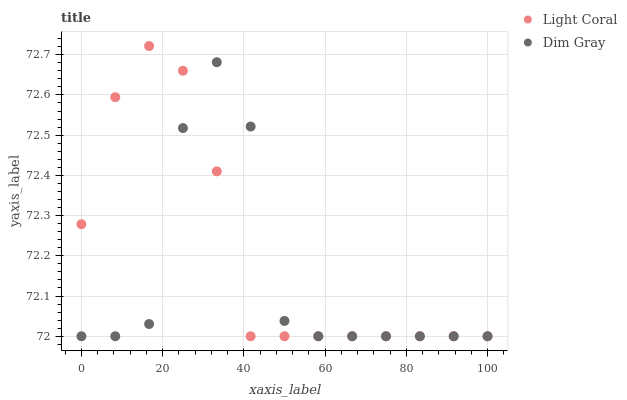Does Dim Gray have the minimum area under the curve?
Answer yes or no. Yes. Does Light Coral have the maximum area under the curve?
Answer yes or no. Yes. Does Dim Gray have the maximum area under the curve?
Answer yes or no. No. Is Light Coral the smoothest?
Answer yes or no. Yes. Is Dim Gray the roughest?
Answer yes or no. Yes. Is Dim Gray the smoothest?
Answer yes or no. No. Does Light Coral have the lowest value?
Answer yes or no. Yes. Does Light Coral have the highest value?
Answer yes or no. Yes. Does Dim Gray have the highest value?
Answer yes or no. No. Does Light Coral intersect Dim Gray?
Answer yes or no. Yes. Is Light Coral less than Dim Gray?
Answer yes or no. No. Is Light Coral greater than Dim Gray?
Answer yes or no. No. 